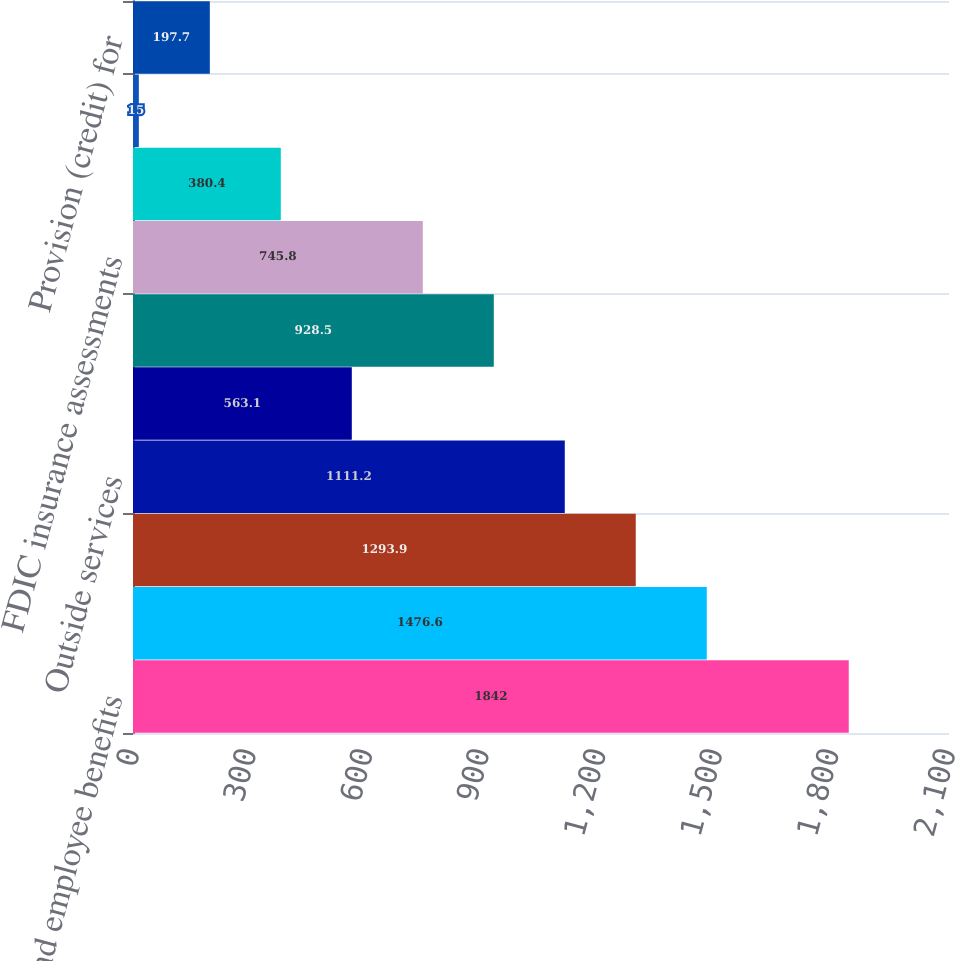Convert chart. <chart><loc_0><loc_0><loc_500><loc_500><bar_chart><fcel>Salaries and employee benefits<fcel>Net occupancy expense<fcel>Furniture and equipment<fcel>Outside services<fcel>Professional legal and<fcel>Marketing<fcel>FDIC insurance assessments<fcel>Branch consolidation property<fcel>Visa class B shares expense<fcel>Provision (credit) for<nl><fcel>1842<fcel>1476.6<fcel>1293.9<fcel>1111.2<fcel>563.1<fcel>928.5<fcel>745.8<fcel>380.4<fcel>15<fcel>197.7<nl></chart> 